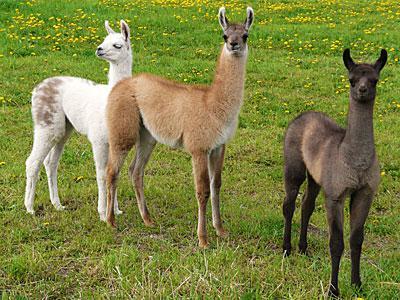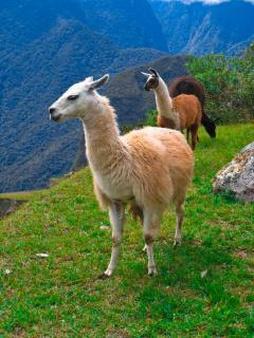The first image is the image on the left, the second image is the image on the right. Analyze the images presented: Is the assertion "A juvenile llama can be seen near an adult llama." valid? Answer yes or no. No. 